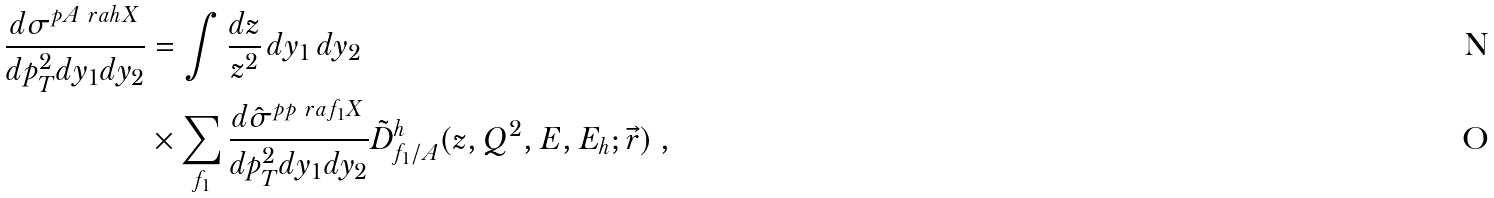Convert formula to latex. <formula><loc_0><loc_0><loc_500><loc_500>\frac { d \sigma ^ { p A \ r a h X } } { d p _ { T } ^ { 2 } d y _ { 1 } d y _ { 2 } } & = \int \frac { d z } { z ^ { 2 } } \, d y _ { 1 } \, d y _ { 2 } \, \\ & \times \sum _ { f _ { 1 } } \frac { d \hat { \sigma } ^ { p p \ r a f _ { 1 } X } } { d p _ { T } ^ { 2 } d y _ { 1 } d y _ { 2 } } \tilde { D } _ { f _ { 1 } / A } ^ { h } ( z , Q ^ { 2 } , E , E _ { h } ; \vec { r } ) \ ,</formula> 